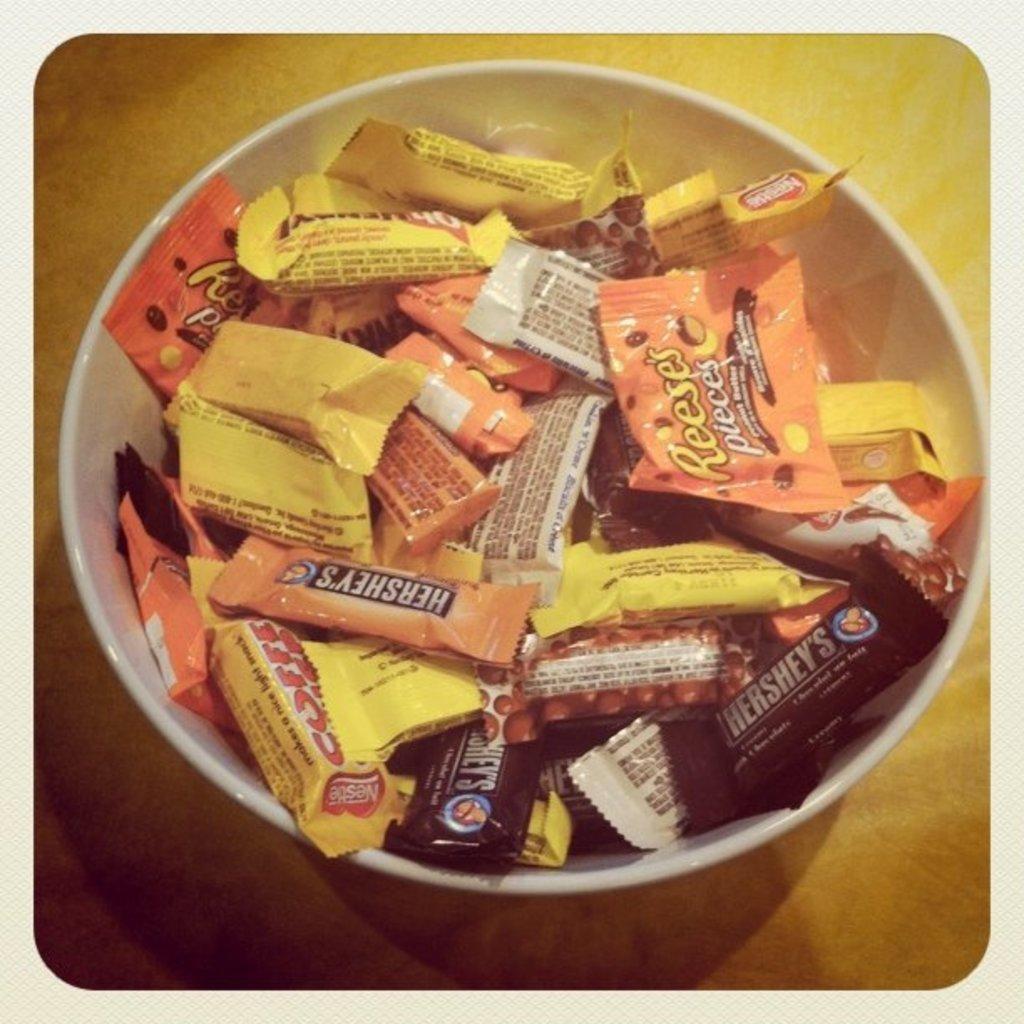Describe this image in one or two sentences. In this picture we can see wrappers placed in a white bowl and this bowl is placed on a platform. 